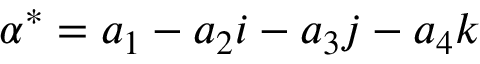<formula> <loc_0><loc_0><loc_500><loc_500>\alpha ^ { * } = a _ { 1 } - a _ { 2 } i - a _ { 3 } j - a _ { 4 } k</formula> 